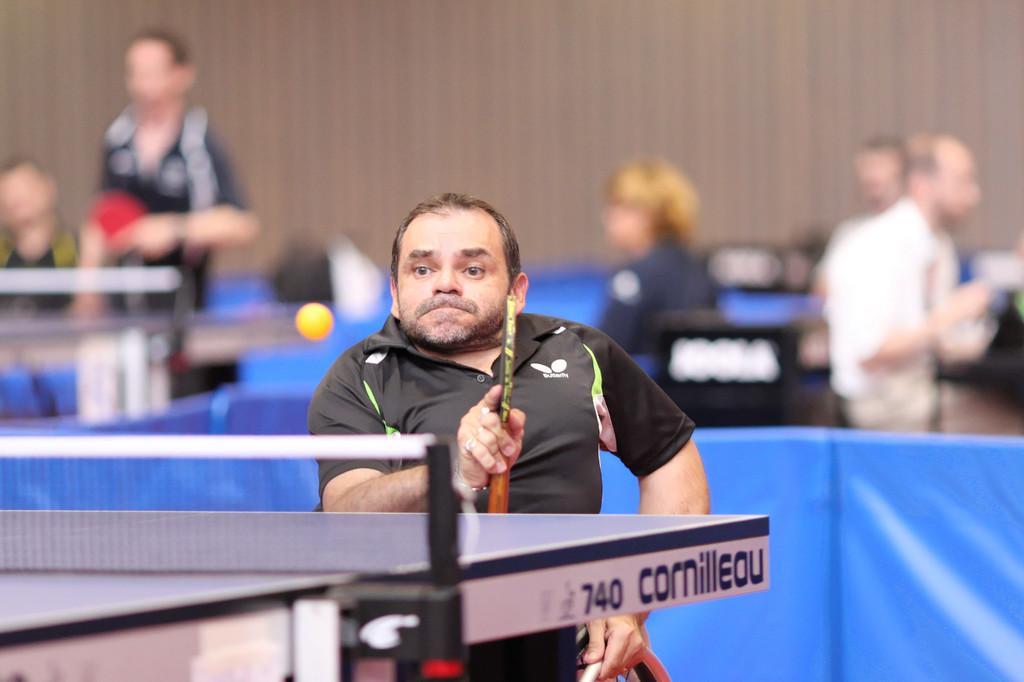Please provide a concise description of this image. In this image I see a man who is holding a bat and he is front of a table, I can also see a ball over here. In the background I see lot of people. 